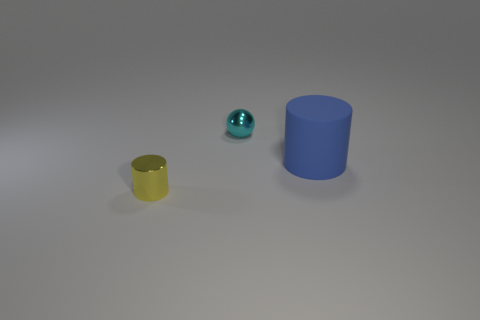What materials do the objects in the image appear to be made from? The yellow object has a matte finish and could be made of ceramic or plastic. The small turquoise sphere has a reflective surface, suggestive of a polished metal or glass. The large blue cylinder seems to have a plastic-like appearance with a matte finish. 